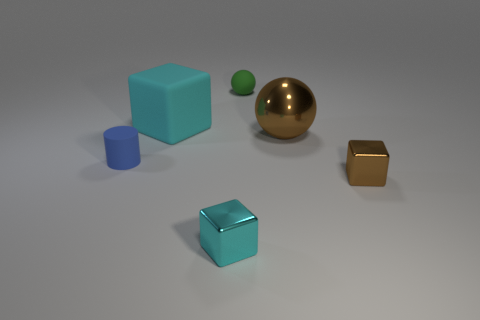Add 2 gray metal things. How many objects exist? 8 Subtract all cylinders. How many objects are left? 5 Subtract all blue cylinders. Subtract all blue matte things. How many objects are left? 4 Add 2 shiny balls. How many shiny balls are left? 3 Add 3 big cyan rubber cylinders. How many big cyan rubber cylinders exist? 3 Subtract 0 yellow cylinders. How many objects are left? 6 